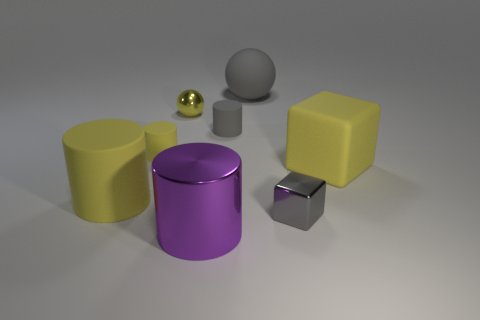Subtract all large purple cylinders. How many cylinders are left? 3 Subtract all green balls. How many yellow cylinders are left? 2 Add 2 yellow cylinders. How many objects exist? 10 Subtract all yellow spheres. How many spheres are left? 1 Subtract 1 cylinders. How many cylinders are left? 3 Subtract all balls. How many objects are left? 6 Subtract all brown metal things. Subtract all small metallic blocks. How many objects are left? 7 Add 4 purple metal objects. How many purple metal objects are left? 5 Add 4 gray metallic blocks. How many gray metallic blocks exist? 5 Subtract 1 gray cylinders. How many objects are left? 7 